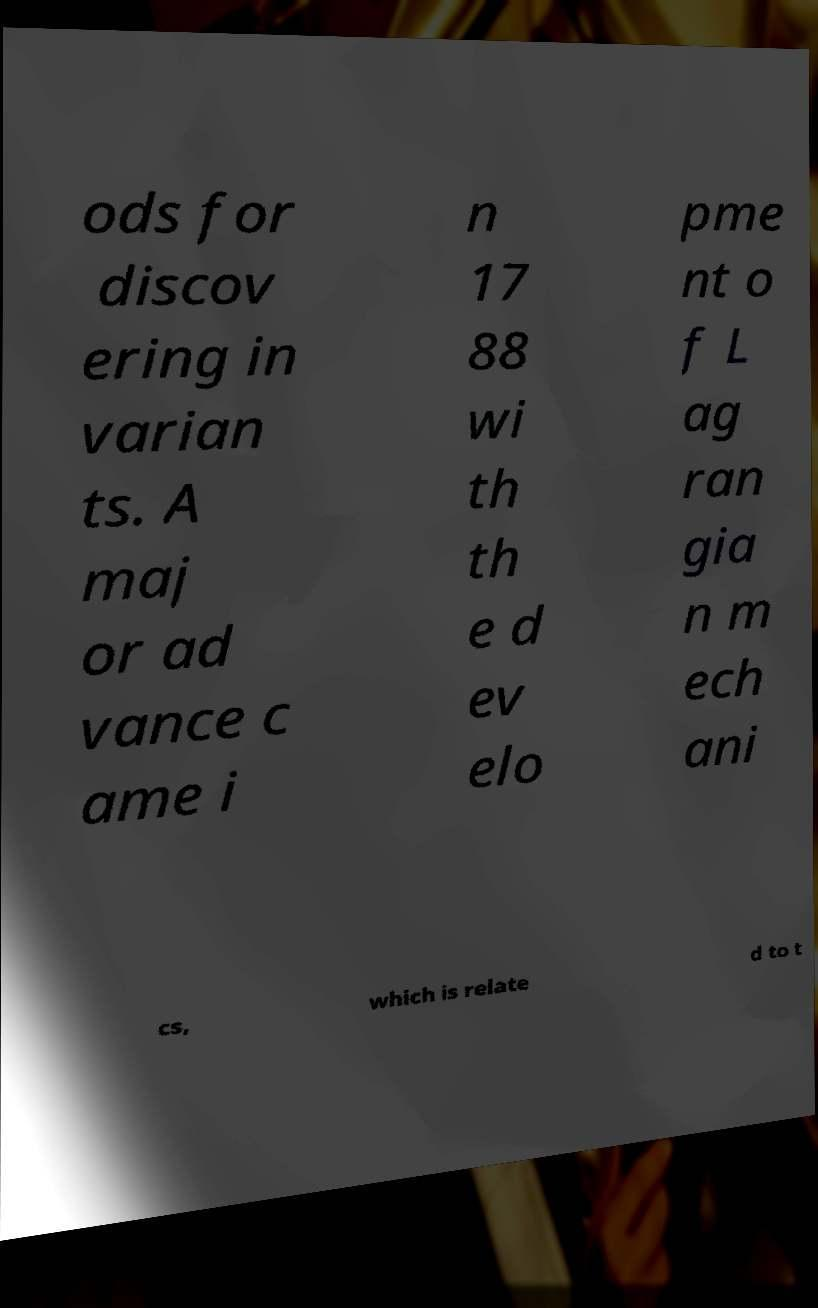Please read and relay the text visible in this image. What does it say? ods for discov ering in varian ts. A maj or ad vance c ame i n 17 88 wi th th e d ev elo pme nt o f L ag ran gia n m ech ani cs, which is relate d to t 